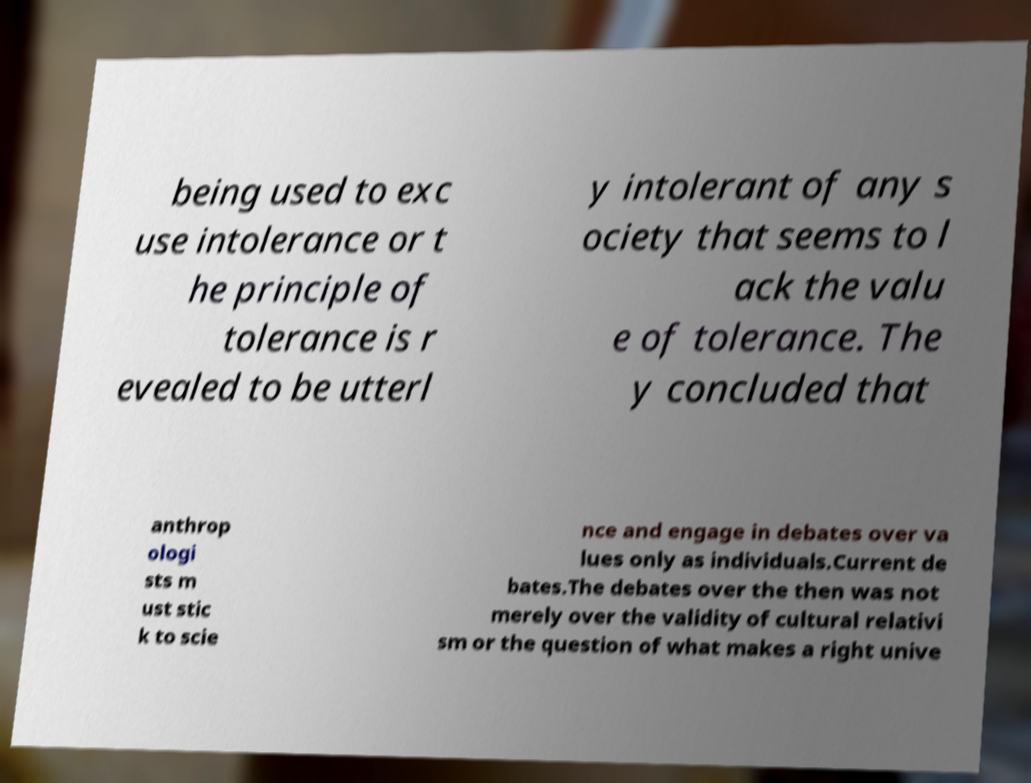Please identify and transcribe the text found in this image. being used to exc use intolerance or t he principle of tolerance is r evealed to be utterl y intolerant of any s ociety that seems to l ack the valu e of tolerance. The y concluded that anthrop ologi sts m ust stic k to scie nce and engage in debates over va lues only as individuals.Current de bates.The debates over the then was not merely over the validity of cultural relativi sm or the question of what makes a right unive 